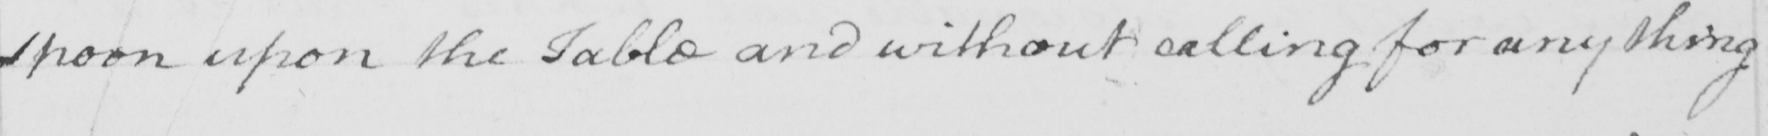What text is written in this handwritten line? spoon upon the Table and without calling for any thing 